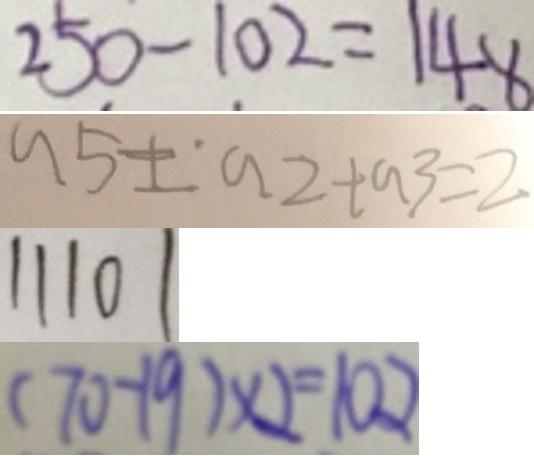Convert formula to latex. <formula><loc_0><loc_0><loc_500><loc_500>2 5 0 - 1 0 2 = 1 4 8 
 a 5 \pm a 2 + a 3 = 2 
 1 1 1 0 1 
 ( 7 0 - 1 9 ) \times 2 = 1 0 2</formula> 